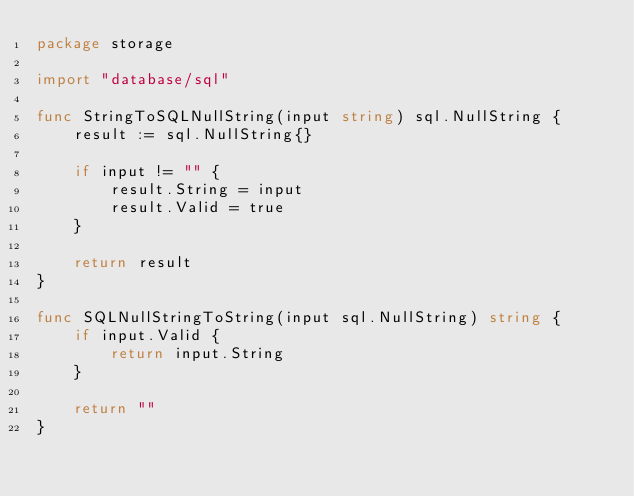<code> <loc_0><loc_0><loc_500><loc_500><_Go_>package storage

import "database/sql"

func StringToSQLNullString(input string) sql.NullString {
	result := sql.NullString{}

	if input != "" {
		result.String = input
		result.Valid = true
	}

	return result
}

func SQLNullStringToString(input sql.NullString) string {
	if input.Valid {
		return input.String
	}

	return ""
}
</code> 